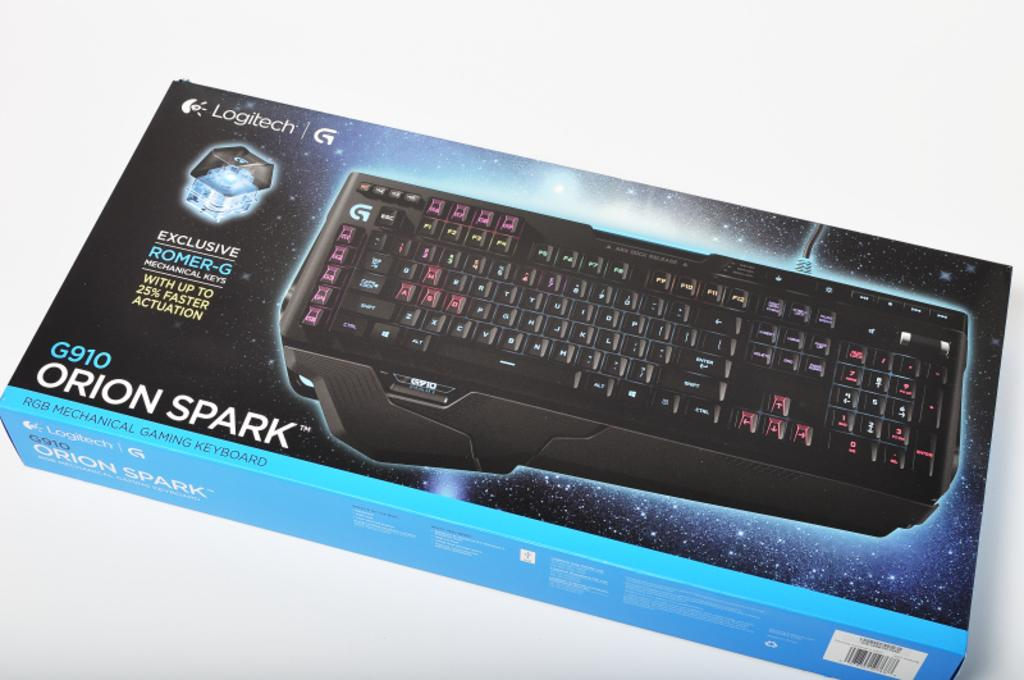<image>
Summarize the visual content of the image. The Logitech Orion Spark keyboard has red and black keys and 25% faster actuation. 